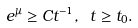<formula> <loc_0><loc_0><loc_500><loc_500>e ^ { \mu } \geq C t ^ { - 1 } , \ t \geq t _ { 0 } .</formula> 